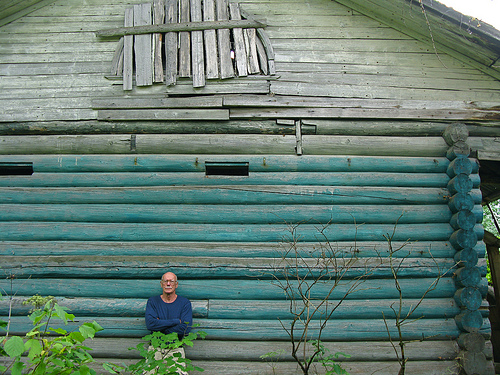<image>
Is the plant behind the man? No. The plant is not behind the man. From this viewpoint, the plant appears to be positioned elsewhere in the scene. 